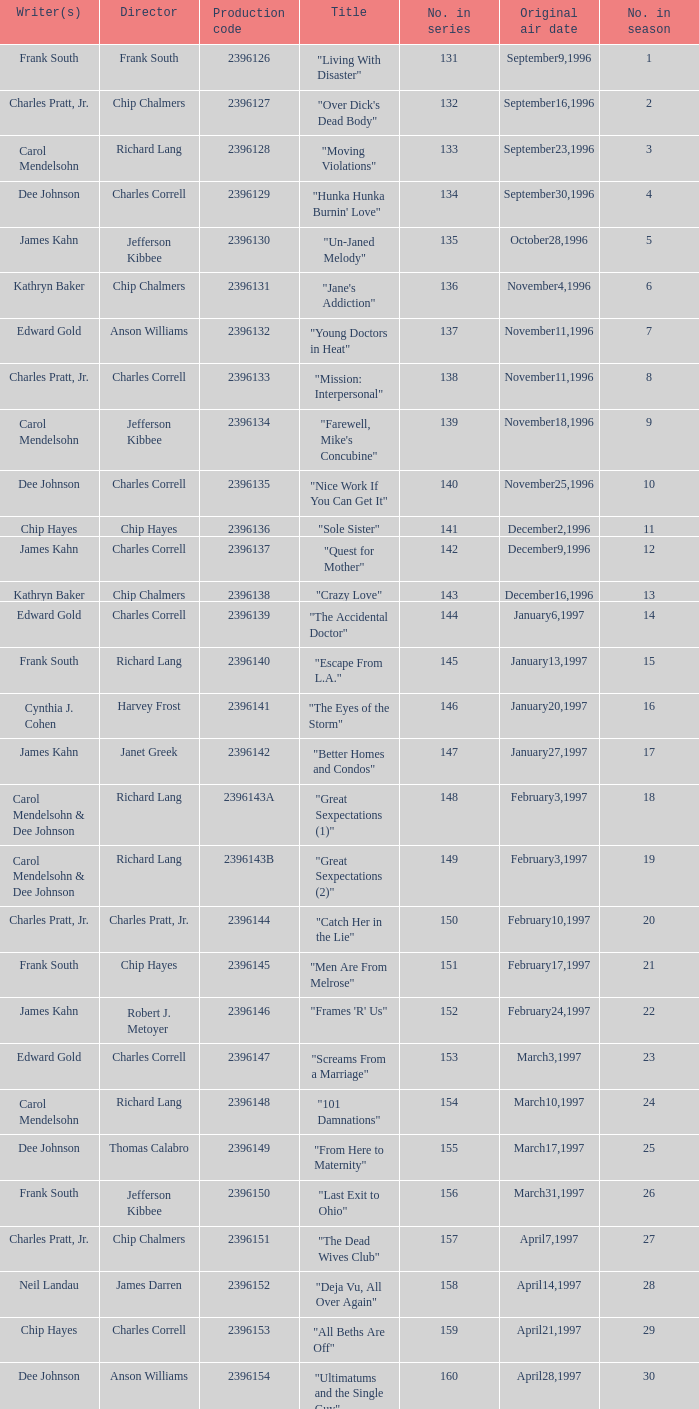Who directed the episode "Great Sexpectations (2)"? Richard Lang. 